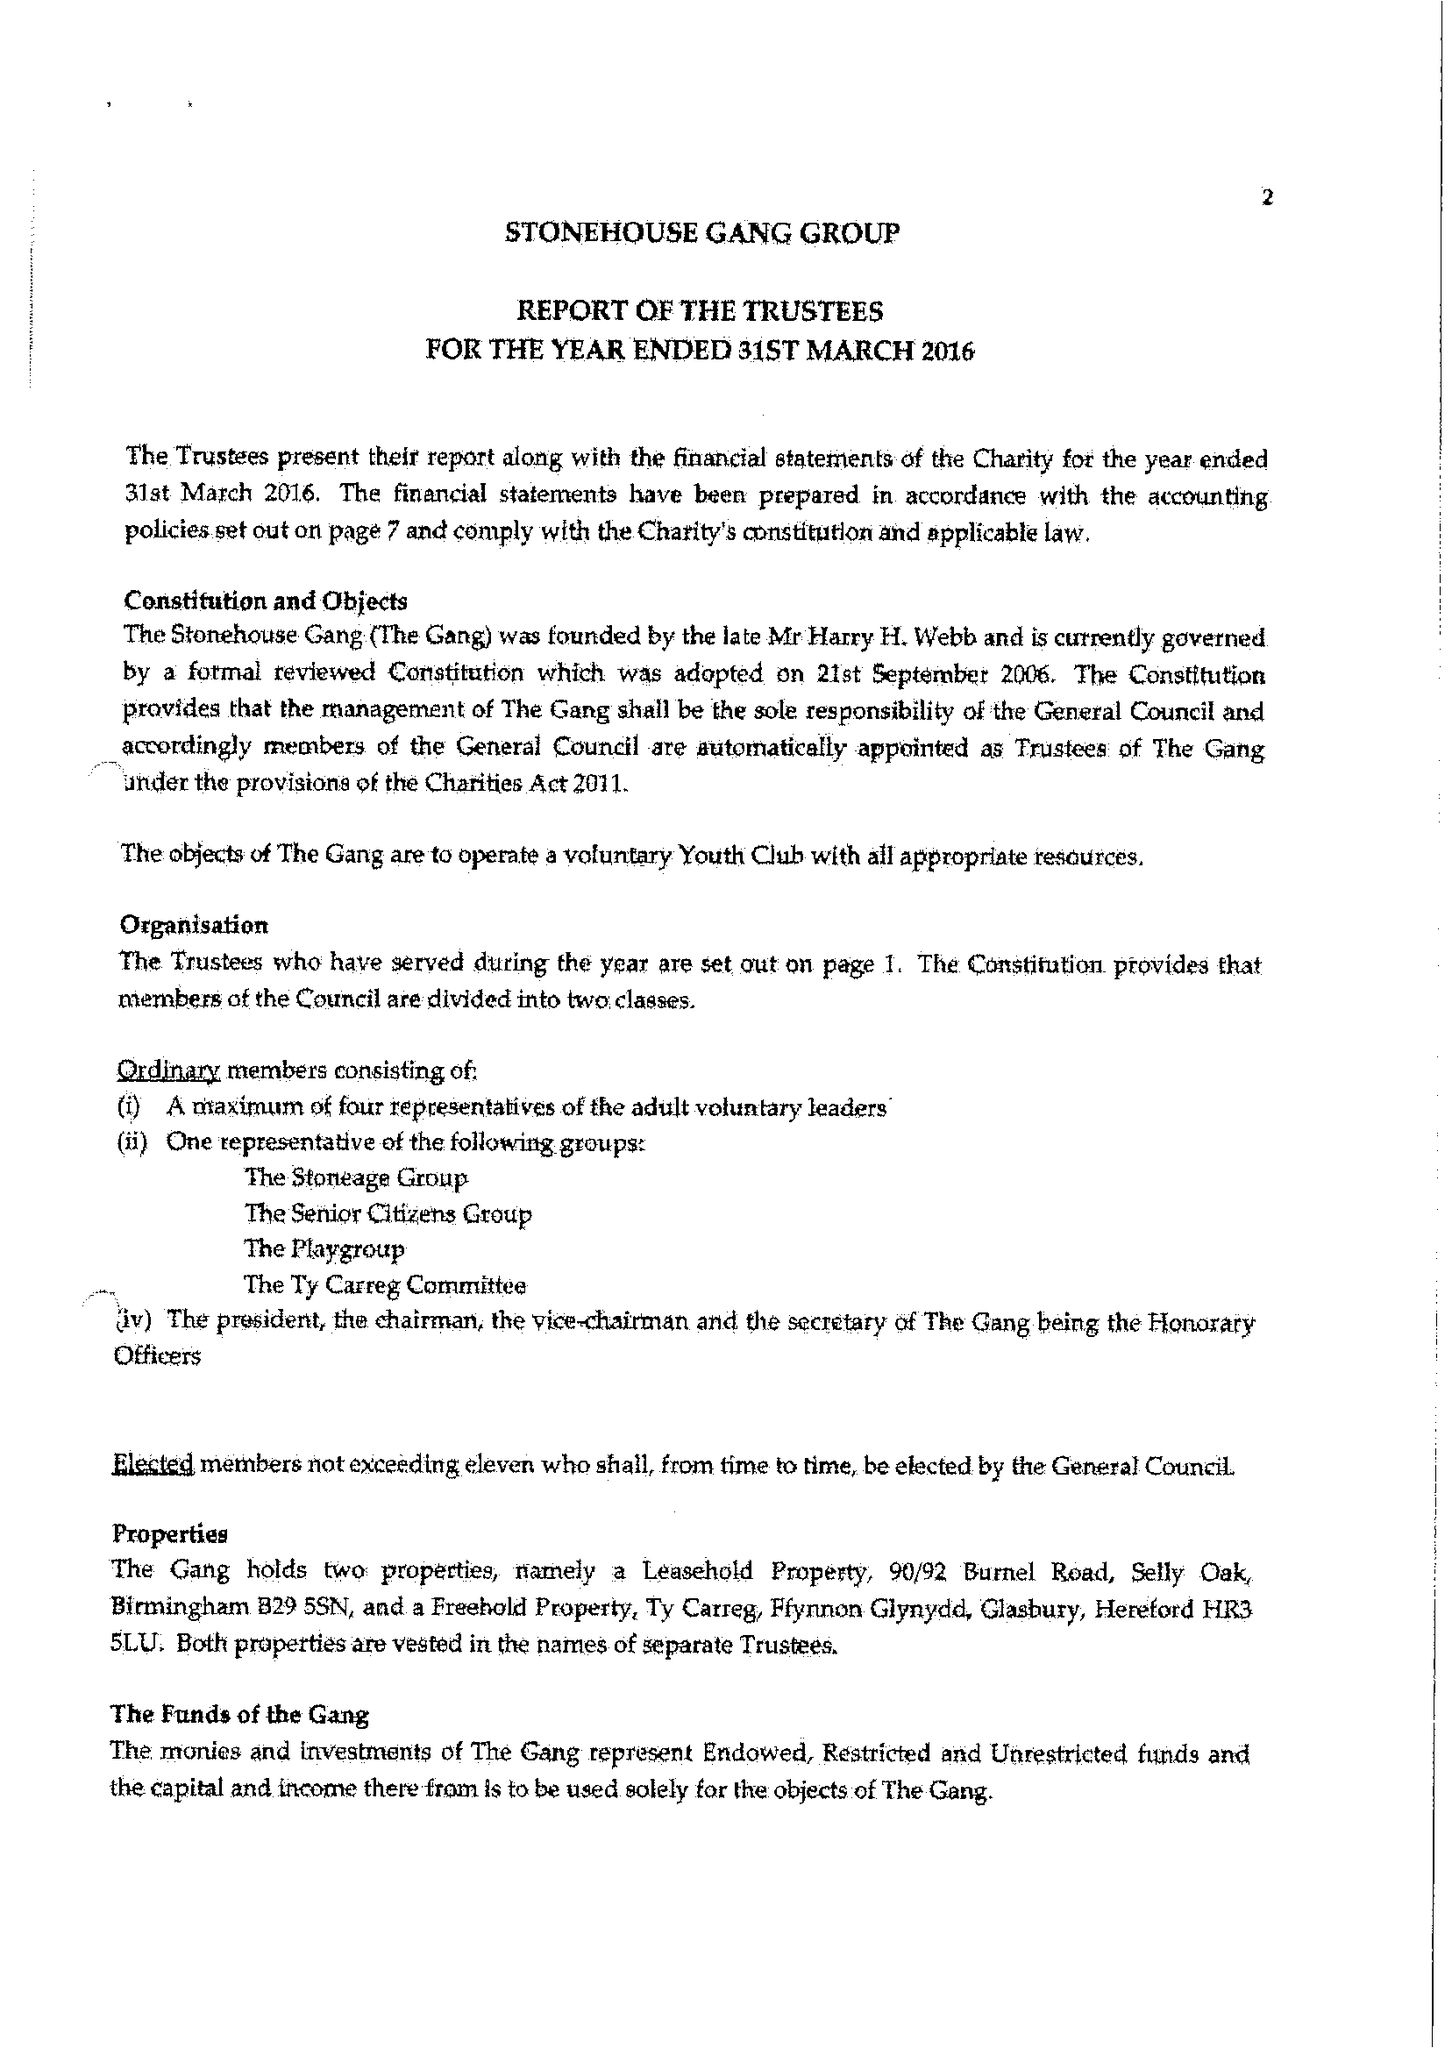What is the value for the address__postcode?
Answer the question using a single word or phrase. DY12 1TJ 